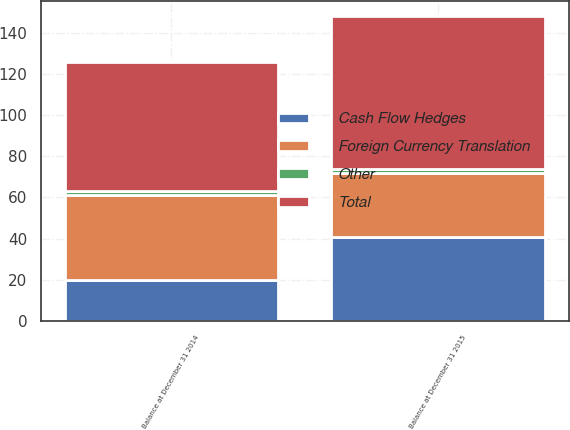Convert chart to OTSL. <chart><loc_0><loc_0><loc_500><loc_500><stacked_bar_chart><ecel><fcel>Balance at December 31 2014<fcel>Balance at December 31 2015<nl><fcel>Foreign Currency Translation<fcel>41<fcel>31<nl><fcel>Cash Flow Hedges<fcel>20<fcel>41<nl><fcel>Other<fcel>2<fcel>2<nl><fcel>Total<fcel>63<fcel>74<nl></chart> 